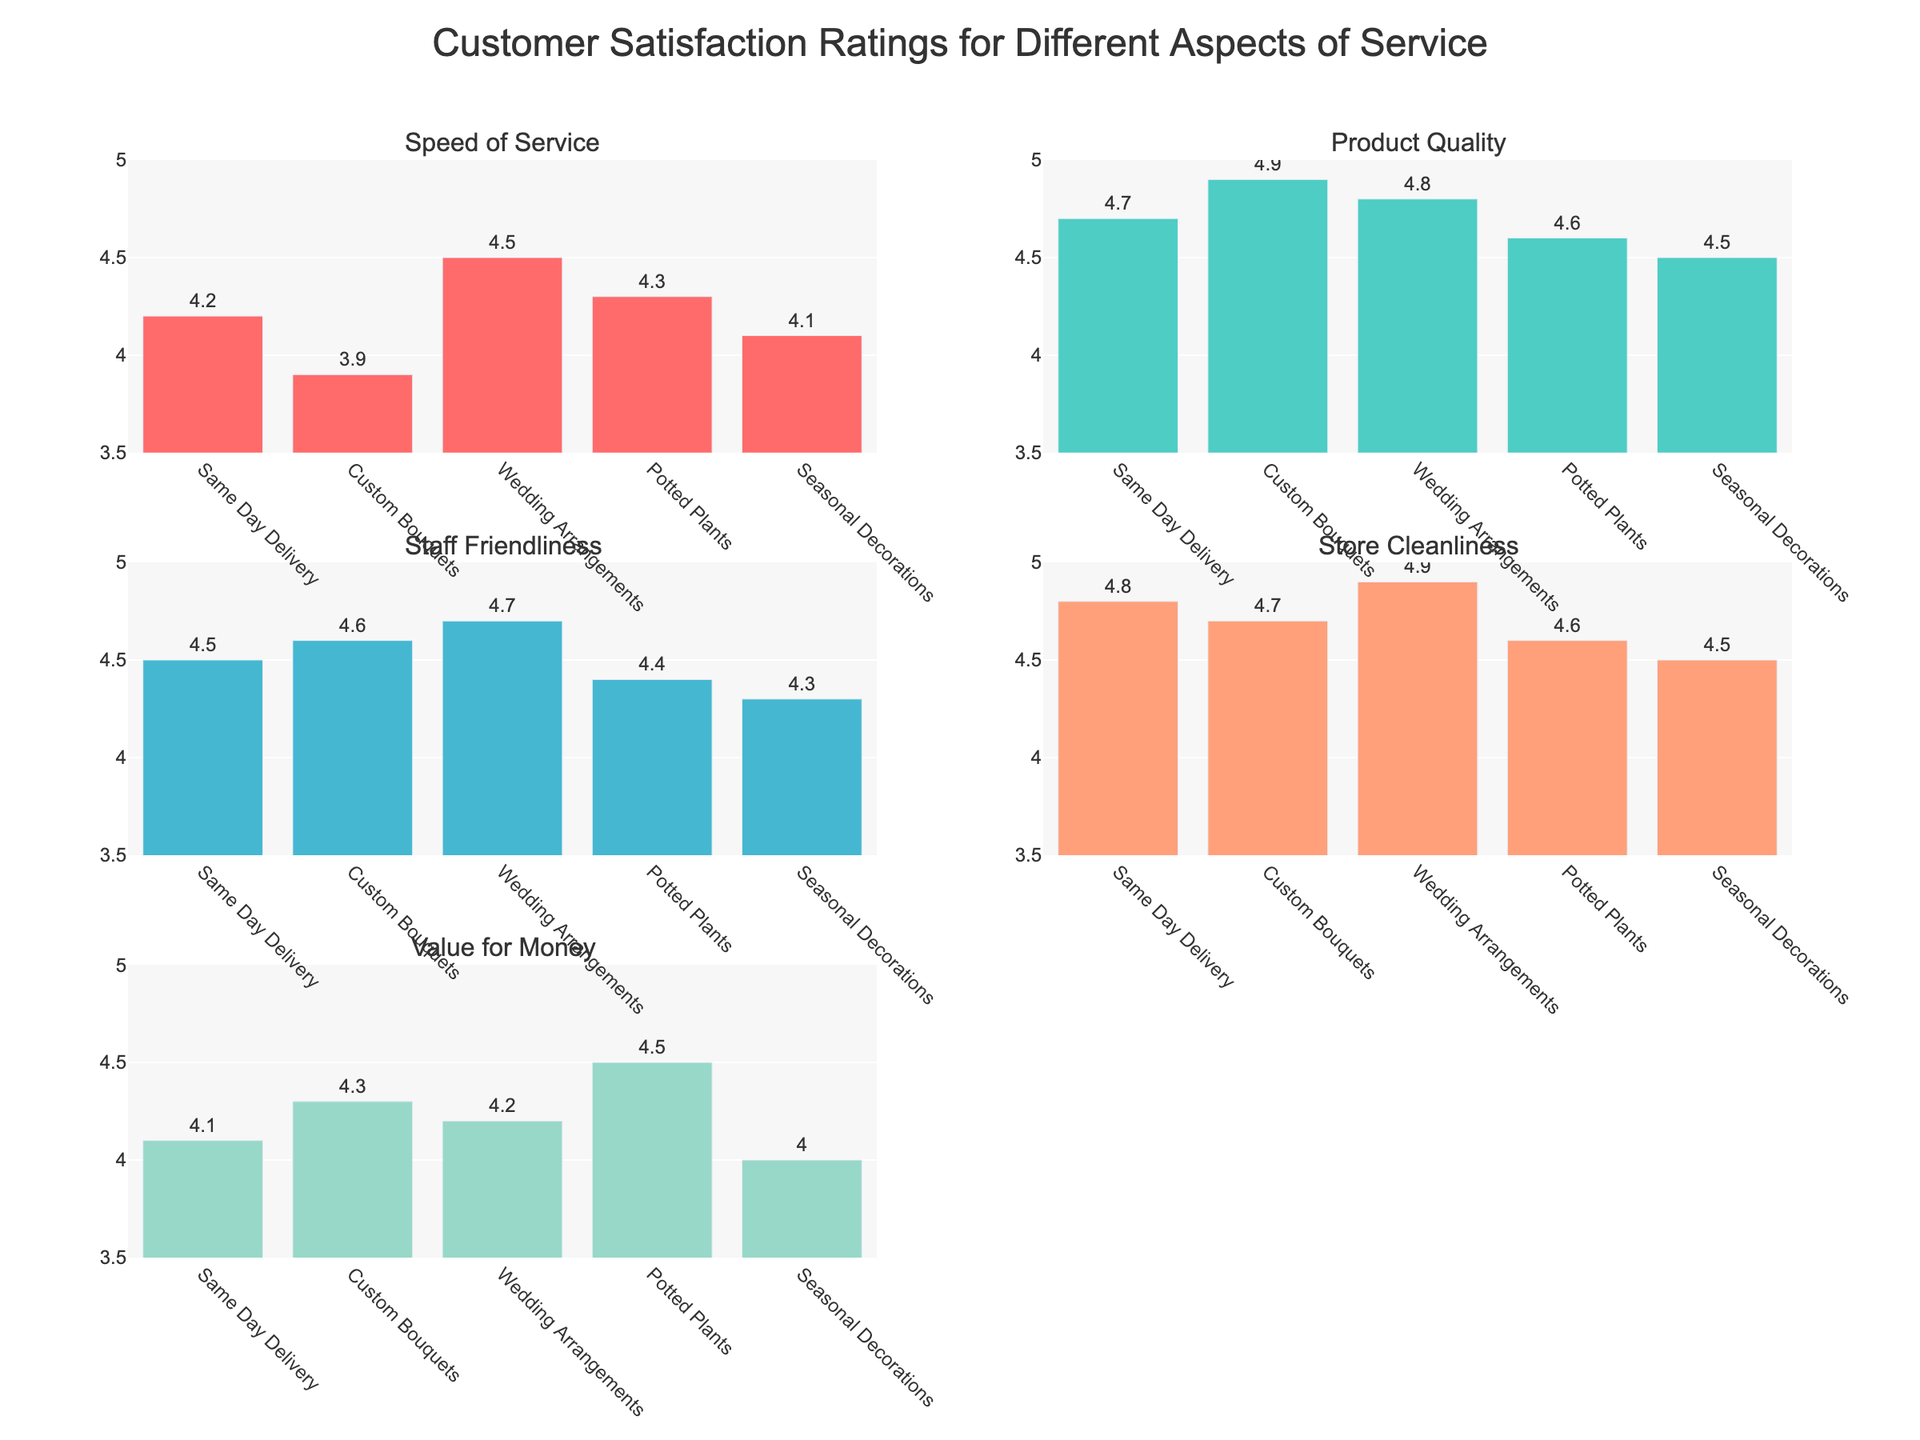What's the title of the figure? The title of the figure is usually located at the top center of the plot. In this case, the title is given explicitly in the code as 'Customer Satisfaction Ratings for Different Aspects of Service'.
Answer: Customer Satisfaction Ratings for Different Aspects of Service What are the five categories of service aspects being rated? The five categories are listed on the x-axes of the subplots. They are 'Same Day Delivery', 'Custom Bouquets', 'Wedding Arrangements', 'Potted Plants', and 'Seasonal Decorations'.
Answer: Same Day Delivery, Custom Bouquets, Wedding Arrangements, Potted Plants, Seasonal Decorations Which service aspect received the highest rating for 'Store Cleanliness'? Look at the subplot for 'Store Cleanliness' and identify the highest bar. 'Wedding Arrangements' received the highest rating of 4.9.
Answer: Wedding Arrangements How do the ratings for 'Product Quality' compare between 'Potted Plants' and 'Seasonal Decorations'? In the 'Product Quality' subplot, compare the heights of the bars for 'Potted Plants' (4.6) and 'Seasonal Decorations' (4.5). 'Potted Plants' is rated slightly higher.
Answer: Potted Plants is rated higher What is the average rating for 'Speed of Service' across all categories? Sum the ratings for 'Speed of Service' and divide by the number of categories: (4.2 + 3.9 + 4.5 + 4.3 + 4.1)/5 = 4.2.
Answer: 4.2 For 'Staff Friendliness', which category has the lowest rating and what is it? Locate the subplot for 'Staff Friendliness' and identify the lowest bar. 'Seasonal Decorations' has the lowest rating of 4.3.
Answer: Seasonal Decorations (4.3) How much higher is the 'Store Cleanliness' rating for 'Wedding Arrangements' compared to 'Custom Bouquets'? Subtract the rating for 'Custom Bouquets' from the rating for 'Wedding Arrangements': 4.9 - 4.7 = 0.2.
Answer: 0.2 What is the range of ratings for 'Value for Money' across all categories? Identify the highest and lowest ratings in the 'Value for Money' subplot. Highest is 4.5 (Potted Plants), and lowest is 4.0 (Seasonal Decorations). The range is 4.5 - 4.0 = 0.5.
Answer: 0.5 Which category has consistent high ratings (above 4.0) across all service aspects? Verify each category for ratings above 4.0 across all subplots. 'Wedding Arrangements' maintains high ratings (4.5, 4.8, 4.7, 4.9, 4.2) across all aspects.
Answer: Wedding Arrangements 